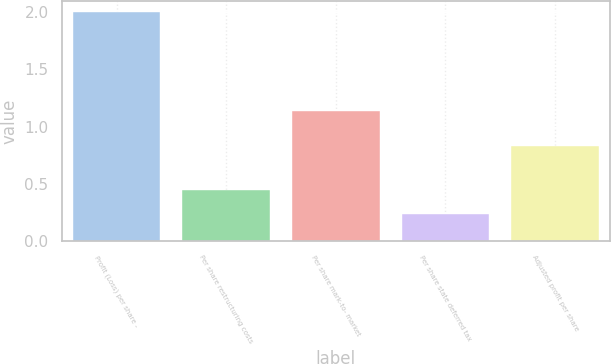Convert chart to OTSL. <chart><loc_0><loc_0><loc_500><loc_500><bar_chart><fcel>Profit (Loss) per share -<fcel>Per share restructuring costs<fcel>Per share mark-to- market<fcel>Per share state deferred tax<fcel>Adjusted profit per share<nl><fcel>2<fcel>0.45<fcel>1.14<fcel>0.24<fcel>0.83<nl></chart> 